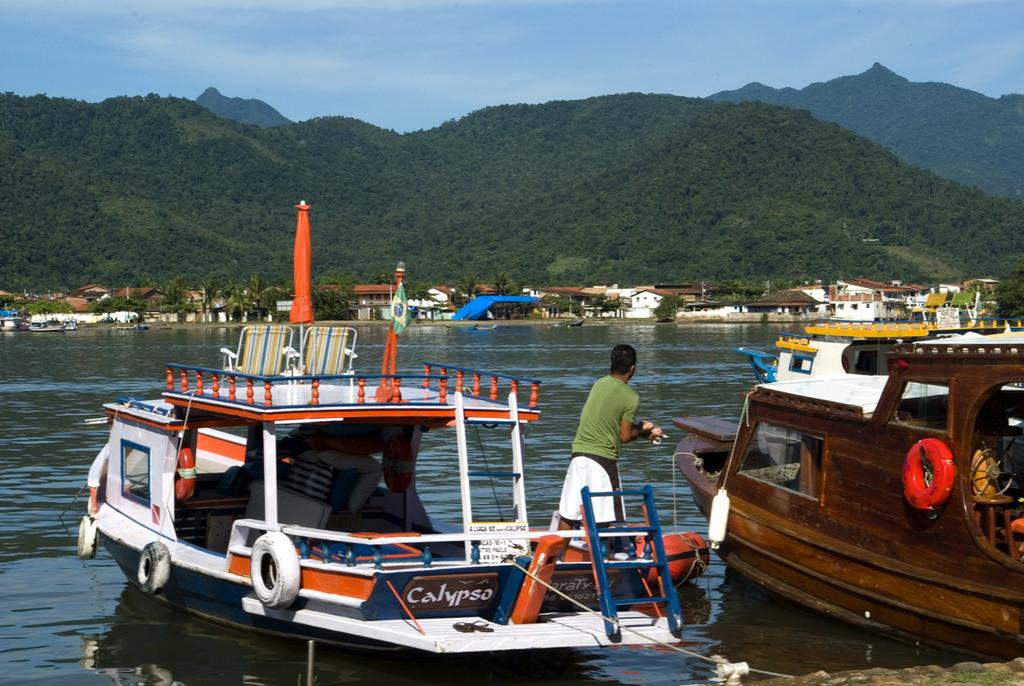What is on the water in the image? There are ships on the water in the image. What is the person holding in the image? The person is holding a thread in the image. What type of structures can be seen in the image? There are houses in the image. What natural features are visible in the image? There are mountains and trees in the image. What part of the natural environment is visible in the image? The sky is visible in the image. What type of pancake is being flipped by the person holding the thread in the image? There is no pancake present in the image, and the person is not flipping anything. What force is being exerted by the ships on the water in the image? The ships are not exerting any force on the water in the image; they are simply floating on it. 